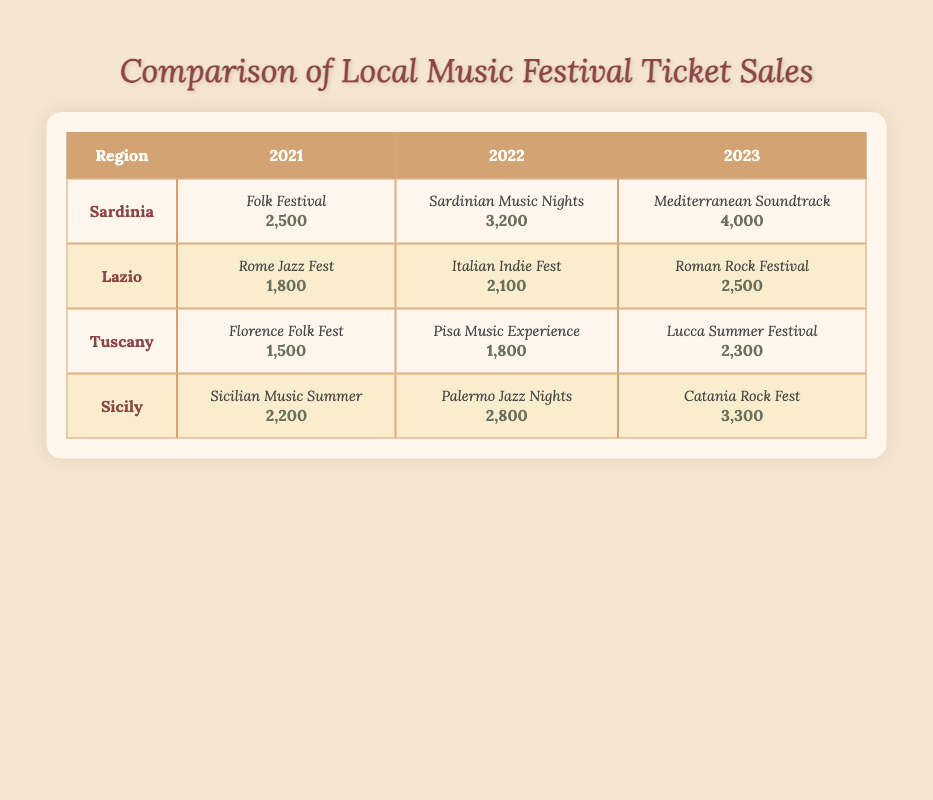What was the highest ticket sales recorded in Sardinia? The table shows the ticket sales for Sardinia over three years. The highest ticket sales in the table are 4000 for the festival "Mediterranean Soundtrack" in 2023.
Answer: 4000 Which region had the lowest ticket sales in 2021? In 2021, the ticket sales recorded were: Sardinia (2500), Lazio (1800), Tuscany (1500), and Sicily (2200). The lowest among these is Tuscany with 1500.
Answer: Tuscany What is the total ticket sales for all festivals in 2023? Summing up the ticket sales for each festival in 2023 gives: Sardinia (4000) + Lazio (2500) + Tuscany (2300) + Sicily (3300). Thus, total sales = 4000 + 2500 + 2300 + 3300 = 12100.
Answer: 12100 Did ticket sales in Lazio increase from 2021 to 2023? In 2021, ticket sales in Lazio were 1800 and in 2023 they were 2500. Since 2500 is greater than 1800, it indicates an increase in ticket sales over this period.
Answer: Yes What was the average ticket sales across all regions for 2022? For 2022 the sales are: Sardinia (3200), Lazio (2100), Tuscany (1800), and Sicily (2800). The total ticket sales sum to 3200 + 2100 + 1800 + 2800 = 9900. Dividing by 4 (the number of regions) gives an average of 9900 / 4 = 2475.
Answer: 2475 Which festival had the highest ticket sales in 2022? Analyzing the ticket sales for 2022: Sardinia (3200), Lazio (2100), Tuscany (1800), and Sicily (2800), the highest among them is "Sardinian Music Nights" in Sardinia with 3200.
Answer: Sardinian Music Nights How many more tickets were sold at the Mediterranean Soundtrack compared to the Rome Jazz Fest? The ticket sales for the Mediterranean Soundtrack in 2023 were 4000 and for the Rome Jazz Fest in 2021 were 1800. Calculating the difference gives 4000 - 1800 = 2200.
Answer: 2200 Were the majority of ticket sales over the three years in Sardinia? Analyzing the total ticket sales for Sardinia over three years: (2500 + 3200 + 4000) = 9700. For the other regions: Lazio (1800 + 2100 + 2500 = 6400), Tuscany (1500 + 1800 + 2300 = 5600), and Sicily (2200 + 2800 + 3300 = 8300). Clearly, 9700 is greater than all other totals, confirming that Sardinia had the most sales.
Answer: Yes 